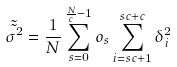<formula> <loc_0><loc_0><loc_500><loc_500>\tilde { \tilde { \sigma ^ { 2 } } } = \frac { 1 } { N } \sum _ { s = 0 } ^ { \frac { N } { c } - 1 } o _ { s } \sum _ { i = s c + 1 } ^ { s c + c } \delta _ { i } ^ { 2 }</formula> 